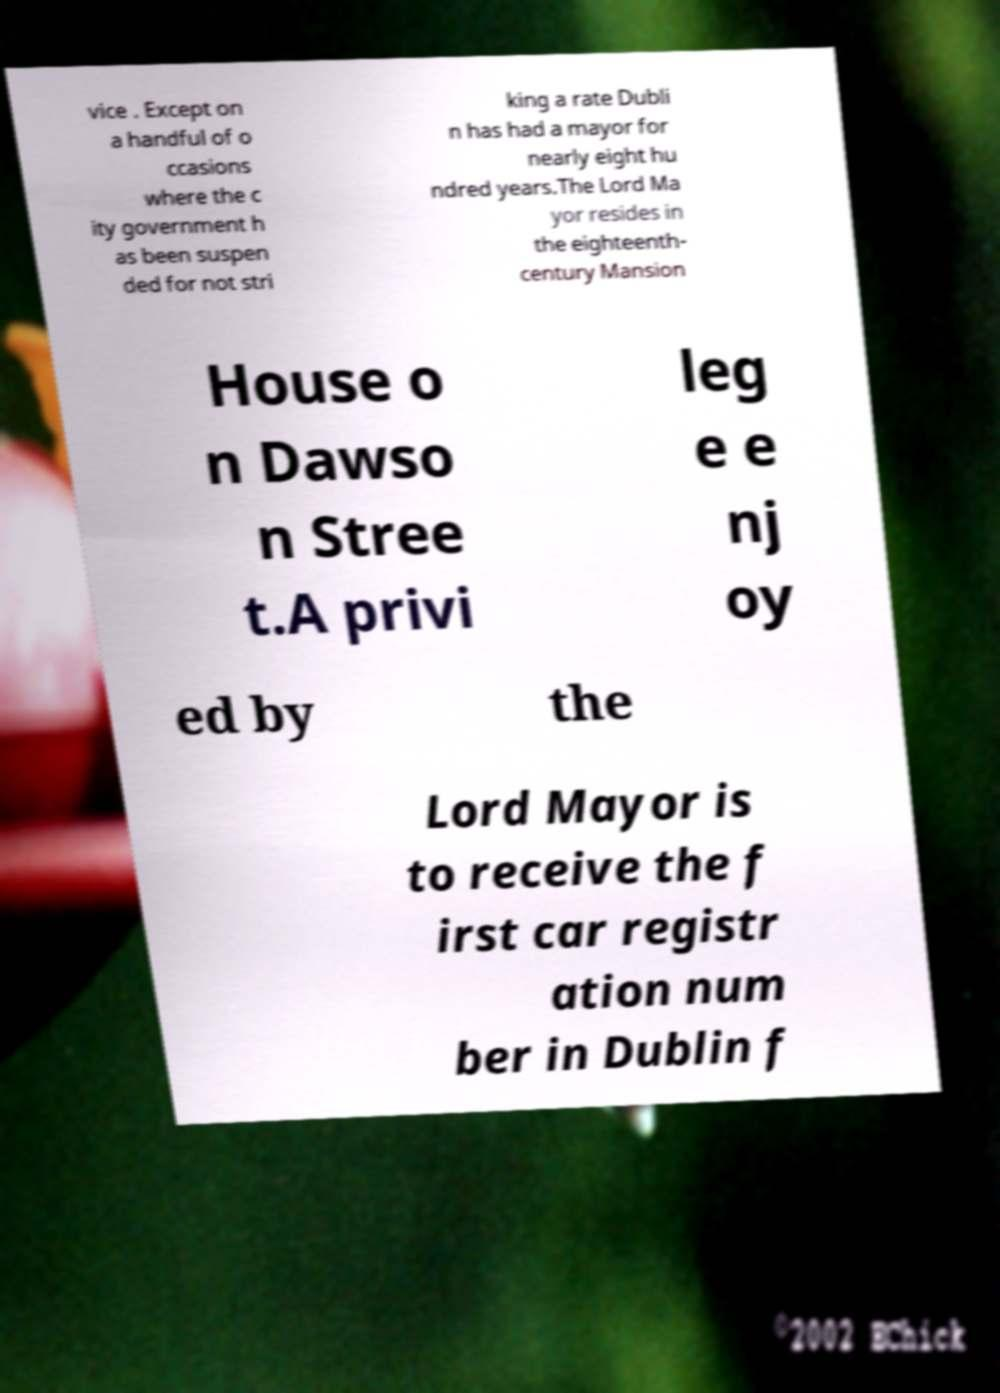Could you extract and type out the text from this image? vice . Except on a handful of o ccasions where the c ity government h as been suspen ded for not stri king a rate Dubli n has had a mayor for nearly eight hu ndred years.The Lord Ma yor resides in the eighteenth- century Mansion House o n Dawso n Stree t.A privi leg e e nj oy ed by the Lord Mayor is to receive the f irst car registr ation num ber in Dublin f 